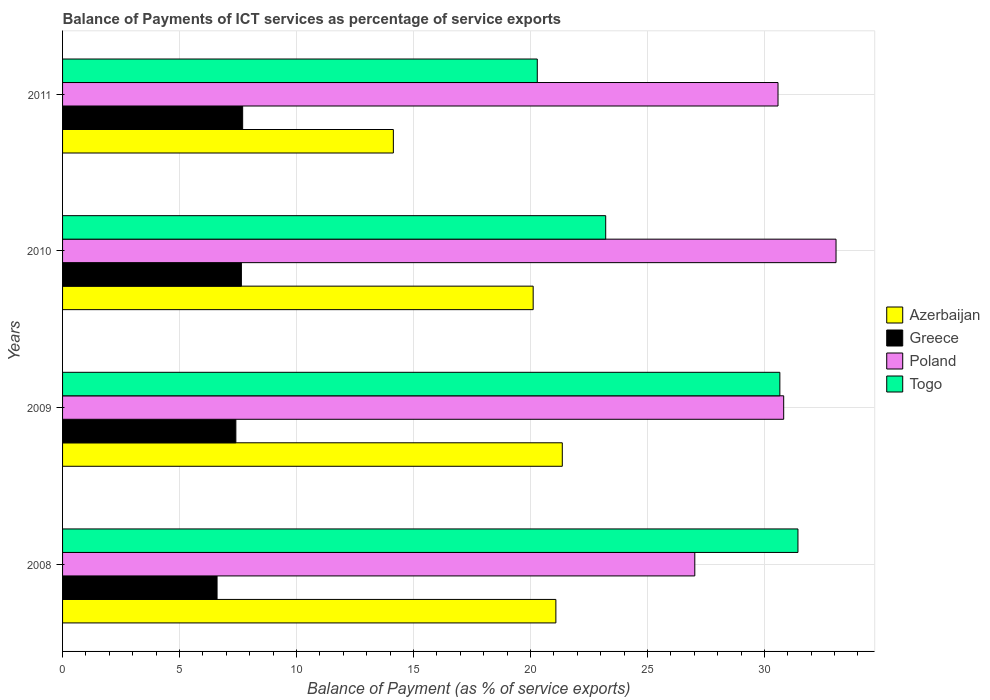How many different coloured bars are there?
Offer a very short reply. 4. Are the number of bars per tick equal to the number of legend labels?
Provide a short and direct response. Yes. In how many cases, is the number of bars for a given year not equal to the number of legend labels?
Offer a very short reply. 0. What is the balance of payments of ICT services in Azerbaijan in 2009?
Provide a succinct answer. 21.36. Across all years, what is the maximum balance of payments of ICT services in Poland?
Ensure brevity in your answer.  33.06. Across all years, what is the minimum balance of payments of ICT services in Poland?
Offer a terse response. 27.02. In which year was the balance of payments of ICT services in Greece maximum?
Your response must be concise. 2011. What is the total balance of payments of ICT services in Togo in the graph?
Your answer should be very brief. 105.6. What is the difference between the balance of payments of ICT services in Togo in 2008 and that in 2011?
Provide a succinct answer. 11.14. What is the difference between the balance of payments of ICT services in Azerbaijan in 2010 and the balance of payments of ICT services in Togo in 2009?
Ensure brevity in your answer.  -10.54. What is the average balance of payments of ICT services in Azerbaijan per year?
Make the answer very short. 19.18. In the year 2008, what is the difference between the balance of payments of ICT services in Greece and balance of payments of ICT services in Togo?
Offer a very short reply. -24.83. What is the ratio of the balance of payments of ICT services in Greece in 2009 to that in 2010?
Ensure brevity in your answer.  0.97. What is the difference between the highest and the second highest balance of payments of ICT services in Azerbaijan?
Give a very brief answer. 0.27. What is the difference between the highest and the lowest balance of payments of ICT services in Poland?
Give a very brief answer. 6.04. In how many years, is the balance of payments of ICT services in Greece greater than the average balance of payments of ICT services in Greece taken over all years?
Make the answer very short. 3. Is the sum of the balance of payments of ICT services in Togo in 2010 and 2011 greater than the maximum balance of payments of ICT services in Poland across all years?
Offer a terse response. Yes. Is it the case that in every year, the sum of the balance of payments of ICT services in Togo and balance of payments of ICT services in Poland is greater than the sum of balance of payments of ICT services in Greece and balance of payments of ICT services in Azerbaijan?
Your answer should be compact. No. What does the 3rd bar from the top in 2011 represents?
Ensure brevity in your answer.  Greece. What does the 4th bar from the bottom in 2009 represents?
Your response must be concise. Togo. How many bars are there?
Ensure brevity in your answer.  16. What is the difference between two consecutive major ticks on the X-axis?
Your answer should be compact. 5. Are the values on the major ticks of X-axis written in scientific E-notation?
Offer a terse response. No. Does the graph contain any zero values?
Your response must be concise. No. Where does the legend appear in the graph?
Your response must be concise. Center right. How are the legend labels stacked?
Provide a succinct answer. Vertical. What is the title of the graph?
Provide a short and direct response. Balance of Payments of ICT services as percentage of service exports. What is the label or title of the X-axis?
Offer a very short reply. Balance of Payment (as % of service exports). What is the label or title of the Y-axis?
Keep it short and to the point. Years. What is the Balance of Payment (as % of service exports) of Azerbaijan in 2008?
Ensure brevity in your answer.  21.09. What is the Balance of Payment (as % of service exports) in Greece in 2008?
Provide a succinct answer. 6.6. What is the Balance of Payment (as % of service exports) in Poland in 2008?
Your answer should be very brief. 27.02. What is the Balance of Payment (as % of service exports) of Togo in 2008?
Your answer should be compact. 31.43. What is the Balance of Payment (as % of service exports) in Azerbaijan in 2009?
Your answer should be compact. 21.36. What is the Balance of Payment (as % of service exports) of Greece in 2009?
Give a very brief answer. 7.41. What is the Balance of Payment (as % of service exports) in Poland in 2009?
Your answer should be compact. 30.82. What is the Balance of Payment (as % of service exports) in Togo in 2009?
Make the answer very short. 30.66. What is the Balance of Payment (as % of service exports) of Azerbaijan in 2010?
Your answer should be compact. 20.12. What is the Balance of Payment (as % of service exports) of Greece in 2010?
Your response must be concise. 7.64. What is the Balance of Payment (as % of service exports) in Poland in 2010?
Ensure brevity in your answer.  33.06. What is the Balance of Payment (as % of service exports) of Togo in 2010?
Give a very brief answer. 23.22. What is the Balance of Payment (as % of service exports) of Azerbaijan in 2011?
Provide a succinct answer. 14.14. What is the Balance of Payment (as % of service exports) of Greece in 2011?
Your answer should be very brief. 7.7. What is the Balance of Payment (as % of service exports) of Poland in 2011?
Offer a terse response. 30.58. What is the Balance of Payment (as % of service exports) in Togo in 2011?
Keep it short and to the point. 20.29. Across all years, what is the maximum Balance of Payment (as % of service exports) in Azerbaijan?
Provide a short and direct response. 21.36. Across all years, what is the maximum Balance of Payment (as % of service exports) of Greece?
Your response must be concise. 7.7. Across all years, what is the maximum Balance of Payment (as % of service exports) of Poland?
Your answer should be very brief. 33.06. Across all years, what is the maximum Balance of Payment (as % of service exports) in Togo?
Give a very brief answer. 31.43. Across all years, what is the minimum Balance of Payment (as % of service exports) of Azerbaijan?
Make the answer very short. 14.14. Across all years, what is the minimum Balance of Payment (as % of service exports) of Greece?
Your answer should be very brief. 6.6. Across all years, what is the minimum Balance of Payment (as % of service exports) of Poland?
Provide a succinct answer. 27.02. Across all years, what is the minimum Balance of Payment (as % of service exports) of Togo?
Provide a succinct answer. 20.29. What is the total Balance of Payment (as % of service exports) in Azerbaijan in the graph?
Offer a very short reply. 76.7. What is the total Balance of Payment (as % of service exports) of Greece in the graph?
Provide a succinct answer. 29.35. What is the total Balance of Payment (as % of service exports) in Poland in the graph?
Provide a succinct answer. 121.49. What is the total Balance of Payment (as % of service exports) in Togo in the graph?
Offer a terse response. 105.6. What is the difference between the Balance of Payment (as % of service exports) in Azerbaijan in 2008 and that in 2009?
Give a very brief answer. -0.27. What is the difference between the Balance of Payment (as % of service exports) in Greece in 2008 and that in 2009?
Ensure brevity in your answer.  -0.8. What is the difference between the Balance of Payment (as % of service exports) in Poland in 2008 and that in 2009?
Your answer should be compact. -3.8. What is the difference between the Balance of Payment (as % of service exports) of Togo in 2008 and that in 2009?
Ensure brevity in your answer.  0.77. What is the difference between the Balance of Payment (as % of service exports) in Azerbaijan in 2008 and that in 2010?
Your response must be concise. 0.97. What is the difference between the Balance of Payment (as % of service exports) of Greece in 2008 and that in 2010?
Your response must be concise. -1.04. What is the difference between the Balance of Payment (as % of service exports) of Poland in 2008 and that in 2010?
Provide a short and direct response. -6.04. What is the difference between the Balance of Payment (as % of service exports) of Togo in 2008 and that in 2010?
Keep it short and to the point. 8.22. What is the difference between the Balance of Payment (as % of service exports) of Azerbaijan in 2008 and that in 2011?
Keep it short and to the point. 6.95. What is the difference between the Balance of Payment (as % of service exports) of Greece in 2008 and that in 2011?
Provide a succinct answer. -1.09. What is the difference between the Balance of Payment (as % of service exports) of Poland in 2008 and that in 2011?
Your answer should be compact. -3.56. What is the difference between the Balance of Payment (as % of service exports) in Togo in 2008 and that in 2011?
Make the answer very short. 11.14. What is the difference between the Balance of Payment (as % of service exports) of Azerbaijan in 2009 and that in 2010?
Your answer should be compact. 1.25. What is the difference between the Balance of Payment (as % of service exports) of Greece in 2009 and that in 2010?
Your response must be concise. -0.24. What is the difference between the Balance of Payment (as % of service exports) of Poland in 2009 and that in 2010?
Give a very brief answer. -2.24. What is the difference between the Balance of Payment (as % of service exports) of Togo in 2009 and that in 2010?
Make the answer very short. 7.44. What is the difference between the Balance of Payment (as % of service exports) in Azerbaijan in 2009 and that in 2011?
Your answer should be compact. 7.22. What is the difference between the Balance of Payment (as % of service exports) of Greece in 2009 and that in 2011?
Offer a very short reply. -0.29. What is the difference between the Balance of Payment (as % of service exports) of Poland in 2009 and that in 2011?
Keep it short and to the point. 0.24. What is the difference between the Balance of Payment (as % of service exports) in Togo in 2009 and that in 2011?
Your response must be concise. 10.37. What is the difference between the Balance of Payment (as % of service exports) of Azerbaijan in 2010 and that in 2011?
Keep it short and to the point. 5.98. What is the difference between the Balance of Payment (as % of service exports) in Greece in 2010 and that in 2011?
Give a very brief answer. -0.05. What is the difference between the Balance of Payment (as % of service exports) in Poland in 2010 and that in 2011?
Your answer should be compact. 2.48. What is the difference between the Balance of Payment (as % of service exports) of Togo in 2010 and that in 2011?
Ensure brevity in your answer.  2.92. What is the difference between the Balance of Payment (as % of service exports) of Azerbaijan in 2008 and the Balance of Payment (as % of service exports) of Greece in 2009?
Your response must be concise. 13.68. What is the difference between the Balance of Payment (as % of service exports) in Azerbaijan in 2008 and the Balance of Payment (as % of service exports) in Poland in 2009?
Provide a succinct answer. -9.74. What is the difference between the Balance of Payment (as % of service exports) in Azerbaijan in 2008 and the Balance of Payment (as % of service exports) in Togo in 2009?
Provide a succinct answer. -9.57. What is the difference between the Balance of Payment (as % of service exports) of Greece in 2008 and the Balance of Payment (as % of service exports) of Poland in 2009?
Your answer should be very brief. -24.22. What is the difference between the Balance of Payment (as % of service exports) of Greece in 2008 and the Balance of Payment (as % of service exports) of Togo in 2009?
Offer a very short reply. -24.06. What is the difference between the Balance of Payment (as % of service exports) of Poland in 2008 and the Balance of Payment (as % of service exports) of Togo in 2009?
Keep it short and to the point. -3.64. What is the difference between the Balance of Payment (as % of service exports) in Azerbaijan in 2008 and the Balance of Payment (as % of service exports) in Greece in 2010?
Provide a succinct answer. 13.44. What is the difference between the Balance of Payment (as % of service exports) of Azerbaijan in 2008 and the Balance of Payment (as % of service exports) of Poland in 2010?
Give a very brief answer. -11.98. What is the difference between the Balance of Payment (as % of service exports) of Azerbaijan in 2008 and the Balance of Payment (as % of service exports) of Togo in 2010?
Your answer should be compact. -2.13. What is the difference between the Balance of Payment (as % of service exports) of Greece in 2008 and the Balance of Payment (as % of service exports) of Poland in 2010?
Provide a short and direct response. -26.46. What is the difference between the Balance of Payment (as % of service exports) in Greece in 2008 and the Balance of Payment (as % of service exports) in Togo in 2010?
Provide a short and direct response. -16.61. What is the difference between the Balance of Payment (as % of service exports) in Poland in 2008 and the Balance of Payment (as % of service exports) in Togo in 2010?
Ensure brevity in your answer.  3.81. What is the difference between the Balance of Payment (as % of service exports) of Azerbaijan in 2008 and the Balance of Payment (as % of service exports) of Greece in 2011?
Offer a terse response. 13.39. What is the difference between the Balance of Payment (as % of service exports) in Azerbaijan in 2008 and the Balance of Payment (as % of service exports) in Poland in 2011?
Ensure brevity in your answer.  -9.5. What is the difference between the Balance of Payment (as % of service exports) in Azerbaijan in 2008 and the Balance of Payment (as % of service exports) in Togo in 2011?
Offer a very short reply. 0.79. What is the difference between the Balance of Payment (as % of service exports) of Greece in 2008 and the Balance of Payment (as % of service exports) of Poland in 2011?
Give a very brief answer. -23.98. What is the difference between the Balance of Payment (as % of service exports) in Greece in 2008 and the Balance of Payment (as % of service exports) in Togo in 2011?
Provide a succinct answer. -13.69. What is the difference between the Balance of Payment (as % of service exports) in Poland in 2008 and the Balance of Payment (as % of service exports) in Togo in 2011?
Provide a succinct answer. 6.73. What is the difference between the Balance of Payment (as % of service exports) in Azerbaijan in 2009 and the Balance of Payment (as % of service exports) in Greece in 2010?
Your response must be concise. 13.72. What is the difference between the Balance of Payment (as % of service exports) of Azerbaijan in 2009 and the Balance of Payment (as % of service exports) of Poland in 2010?
Your response must be concise. -11.7. What is the difference between the Balance of Payment (as % of service exports) of Azerbaijan in 2009 and the Balance of Payment (as % of service exports) of Togo in 2010?
Provide a short and direct response. -1.86. What is the difference between the Balance of Payment (as % of service exports) of Greece in 2009 and the Balance of Payment (as % of service exports) of Poland in 2010?
Your answer should be compact. -25.65. What is the difference between the Balance of Payment (as % of service exports) of Greece in 2009 and the Balance of Payment (as % of service exports) of Togo in 2010?
Your response must be concise. -15.81. What is the difference between the Balance of Payment (as % of service exports) in Poland in 2009 and the Balance of Payment (as % of service exports) in Togo in 2010?
Keep it short and to the point. 7.61. What is the difference between the Balance of Payment (as % of service exports) in Azerbaijan in 2009 and the Balance of Payment (as % of service exports) in Greece in 2011?
Keep it short and to the point. 13.66. What is the difference between the Balance of Payment (as % of service exports) in Azerbaijan in 2009 and the Balance of Payment (as % of service exports) in Poland in 2011?
Your response must be concise. -9.22. What is the difference between the Balance of Payment (as % of service exports) in Azerbaijan in 2009 and the Balance of Payment (as % of service exports) in Togo in 2011?
Offer a terse response. 1.07. What is the difference between the Balance of Payment (as % of service exports) in Greece in 2009 and the Balance of Payment (as % of service exports) in Poland in 2011?
Provide a succinct answer. -23.17. What is the difference between the Balance of Payment (as % of service exports) in Greece in 2009 and the Balance of Payment (as % of service exports) in Togo in 2011?
Provide a short and direct response. -12.88. What is the difference between the Balance of Payment (as % of service exports) of Poland in 2009 and the Balance of Payment (as % of service exports) of Togo in 2011?
Offer a very short reply. 10.53. What is the difference between the Balance of Payment (as % of service exports) of Azerbaijan in 2010 and the Balance of Payment (as % of service exports) of Greece in 2011?
Ensure brevity in your answer.  12.42. What is the difference between the Balance of Payment (as % of service exports) in Azerbaijan in 2010 and the Balance of Payment (as % of service exports) in Poland in 2011?
Give a very brief answer. -10.47. What is the difference between the Balance of Payment (as % of service exports) of Azerbaijan in 2010 and the Balance of Payment (as % of service exports) of Togo in 2011?
Ensure brevity in your answer.  -0.18. What is the difference between the Balance of Payment (as % of service exports) in Greece in 2010 and the Balance of Payment (as % of service exports) in Poland in 2011?
Provide a short and direct response. -22.94. What is the difference between the Balance of Payment (as % of service exports) in Greece in 2010 and the Balance of Payment (as % of service exports) in Togo in 2011?
Keep it short and to the point. -12.65. What is the difference between the Balance of Payment (as % of service exports) of Poland in 2010 and the Balance of Payment (as % of service exports) of Togo in 2011?
Offer a very short reply. 12.77. What is the average Balance of Payment (as % of service exports) of Azerbaijan per year?
Your answer should be very brief. 19.18. What is the average Balance of Payment (as % of service exports) in Greece per year?
Provide a short and direct response. 7.34. What is the average Balance of Payment (as % of service exports) of Poland per year?
Give a very brief answer. 30.37. What is the average Balance of Payment (as % of service exports) in Togo per year?
Offer a very short reply. 26.4. In the year 2008, what is the difference between the Balance of Payment (as % of service exports) of Azerbaijan and Balance of Payment (as % of service exports) of Greece?
Your answer should be compact. 14.48. In the year 2008, what is the difference between the Balance of Payment (as % of service exports) of Azerbaijan and Balance of Payment (as % of service exports) of Poland?
Your response must be concise. -5.94. In the year 2008, what is the difference between the Balance of Payment (as % of service exports) in Azerbaijan and Balance of Payment (as % of service exports) in Togo?
Provide a short and direct response. -10.35. In the year 2008, what is the difference between the Balance of Payment (as % of service exports) in Greece and Balance of Payment (as % of service exports) in Poland?
Ensure brevity in your answer.  -20.42. In the year 2008, what is the difference between the Balance of Payment (as % of service exports) of Greece and Balance of Payment (as % of service exports) of Togo?
Offer a very short reply. -24.83. In the year 2008, what is the difference between the Balance of Payment (as % of service exports) in Poland and Balance of Payment (as % of service exports) in Togo?
Offer a very short reply. -4.41. In the year 2009, what is the difference between the Balance of Payment (as % of service exports) in Azerbaijan and Balance of Payment (as % of service exports) in Greece?
Provide a short and direct response. 13.95. In the year 2009, what is the difference between the Balance of Payment (as % of service exports) in Azerbaijan and Balance of Payment (as % of service exports) in Poland?
Provide a short and direct response. -9.46. In the year 2009, what is the difference between the Balance of Payment (as % of service exports) of Azerbaijan and Balance of Payment (as % of service exports) of Togo?
Offer a very short reply. -9.3. In the year 2009, what is the difference between the Balance of Payment (as % of service exports) in Greece and Balance of Payment (as % of service exports) in Poland?
Provide a succinct answer. -23.42. In the year 2009, what is the difference between the Balance of Payment (as % of service exports) of Greece and Balance of Payment (as % of service exports) of Togo?
Give a very brief answer. -23.25. In the year 2009, what is the difference between the Balance of Payment (as % of service exports) of Poland and Balance of Payment (as % of service exports) of Togo?
Give a very brief answer. 0.16. In the year 2010, what is the difference between the Balance of Payment (as % of service exports) in Azerbaijan and Balance of Payment (as % of service exports) in Greece?
Make the answer very short. 12.47. In the year 2010, what is the difference between the Balance of Payment (as % of service exports) in Azerbaijan and Balance of Payment (as % of service exports) in Poland?
Your answer should be very brief. -12.95. In the year 2010, what is the difference between the Balance of Payment (as % of service exports) in Azerbaijan and Balance of Payment (as % of service exports) in Togo?
Give a very brief answer. -3.1. In the year 2010, what is the difference between the Balance of Payment (as % of service exports) in Greece and Balance of Payment (as % of service exports) in Poland?
Your response must be concise. -25.42. In the year 2010, what is the difference between the Balance of Payment (as % of service exports) in Greece and Balance of Payment (as % of service exports) in Togo?
Your response must be concise. -15.57. In the year 2010, what is the difference between the Balance of Payment (as % of service exports) in Poland and Balance of Payment (as % of service exports) in Togo?
Your answer should be compact. 9.85. In the year 2011, what is the difference between the Balance of Payment (as % of service exports) of Azerbaijan and Balance of Payment (as % of service exports) of Greece?
Your answer should be compact. 6.44. In the year 2011, what is the difference between the Balance of Payment (as % of service exports) of Azerbaijan and Balance of Payment (as % of service exports) of Poland?
Provide a short and direct response. -16.44. In the year 2011, what is the difference between the Balance of Payment (as % of service exports) of Azerbaijan and Balance of Payment (as % of service exports) of Togo?
Your answer should be very brief. -6.15. In the year 2011, what is the difference between the Balance of Payment (as % of service exports) of Greece and Balance of Payment (as % of service exports) of Poland?
Your response must be concise. -22.88. In the year 2011, what is the difference between the Balance of Payment (as % of service exports) in Greece and Balance of Payment (as % of service exports) in Togo?
Keep it short and to the point. -12.59. In the year 2011, what is the difference between the Balance of Payment (as % of service exports) of Poland and Balance of Payment (as % of service exports) of Togo?
Your response must be concise. 10.29. What is the ratio of the Balance of Payment (as % of service exports) in Azerbaijan in 2008 to that in 2009?
Offer a terse response. 0.99. What is the ratio of the Balance of Payment (as % of service exports) in Greece in 2008 to that in 2009?
Keep it short and to the point. 0.89. What is the ratio of the Balance of Payment (as % of service exports) of Poland in 2008 to that in 2009?
Make the answer very short. 0.88. What is the ratio of the Balance of Payment (as % of service exports) in Togo in 2008 to that in 2009?
Offer a terse response. 1.03. What is the ratio of the Balance of Payment (as % of service exports) in Azerbaijan in 2008 to that in 2010?
Provide a short and direct response. 1.05. What is the ratio of the Balance of Payment (as % of service exports) of Greece in 2008 to that in 2010?
Your answer should be very brief. 0.86. What is the ratio of the Balance of Payment (as % of service exports) in Poland in 2008 to that in 2010?
Make the answer very short. 0.82. What is the ratio of the Balance of Payment (as % of service exports) in Togo in 2008 to that in 2010?
Ensure brevity in your answer.  1.35. What is the ratio of the Balance of Payment (as % of service exports) in Azerbaijan in 2008 to that in 2011?
Your response must be concise. 1.49. What is the ratio of the Balance of Payment (as % of service exports) of Greece in 2008 to that in 2011?
Give a very brief answer. 0.86. What is the ratio of the Balance of Payment (as % of service exports) in Poland in 2008 to that in 2011?
Provide a short and direct response. 0.88. What is the ratio of the Balance of Payment (as % of service exports) in Togo in 2008 to that in 2011?
Keep it short and to the point. 1.55. What is the ratio of the Balance of Payment (as % of service exports) of Azerbaijan in 2009 to that in 2010?
Keep it short and to the point. 1.06. What is the ratio of the Balance of Payment (as % of service exports) in Greece in 2009 to that in 2010?
Your answer should be very brief. 0.97. What is the ratio of the Balance of Payment (as % of service exports) of Poland in 2009 to that in 2010?
Give a very brief answer. 0.93. What is the ratio of the Balance of Payment (as % of service exports) in Togo in 2009 to that in 2010?
Your answer should be very brief. 1.32. What is the ratio of the Balance of Payment (as % of service exports) in Azerbaijan in 2009 to that in 2011?
Your answer should be compact. 1.51. What is the ratio of the Balance of Payment (as % of service exports) of Greece in 2009 to that in 2011?
Your answer should be very brief. 0.96. What is the ratio of the Balance of Payment (as % of service exports) in Poland in 2009 to that in 2011?
Provide a succinct answer. 1.01. What is the ratio of the Balance of Payment (as % of service exports) of Togo in 2009 to that in 2011?
Offer a very short reply. 1.51. What is the ratio of the Balance of Payment (as % of service exports) in Azerbaijan in 2010 to that in 2011?
Your response must be concise. 1.42. What is the ratio of the Balance of Payment (as % of service exports) of Poland in 2010 to that in 2011?
Offer a terse response. 1.08. What is the ratio of the Balance of Payment (as % of service exports) of Togo in 2010 to that in 2011?
Ensure brevity in your answer.  1.14. What is the difference between the highest and the second highest Balance of Payment (as % of service exports) of Azerbaijan?
Your answer should be very brief. 0.27. What is the difference between the highest and the second highest Balance of Payment (as % of service exports) in Greece?
Provide a short and direct response. 0.05. What is the difference between the highest and the second highest Balance of Payment (as % of service exports) in Poland?
Offer a very short reply. 2.24. What is the difference between the highest and the second highest Balance of Payment (as % of service exports) in Togo?
Ensure brevity in your answer.  0.77. What is the difference between the highest and the lowest Balance of Payment (as % of service exports) in Azerbaijan?
Give a very brief answer. 7.22. What is the difference between the highest and the lowest Balance of Payment (as % of service exports) of Greece?
Ensure brevity in your answer.  1.09. What is the difference between the highest and the lowest Balance of Payment (as % of service exports) of Poland?
Your response must be concise. 6.04. What is the difference between the highest and the lowest Balance of Payment (as % of service exports) in Togo?
Ensure brevity in your answer.  11.14. 